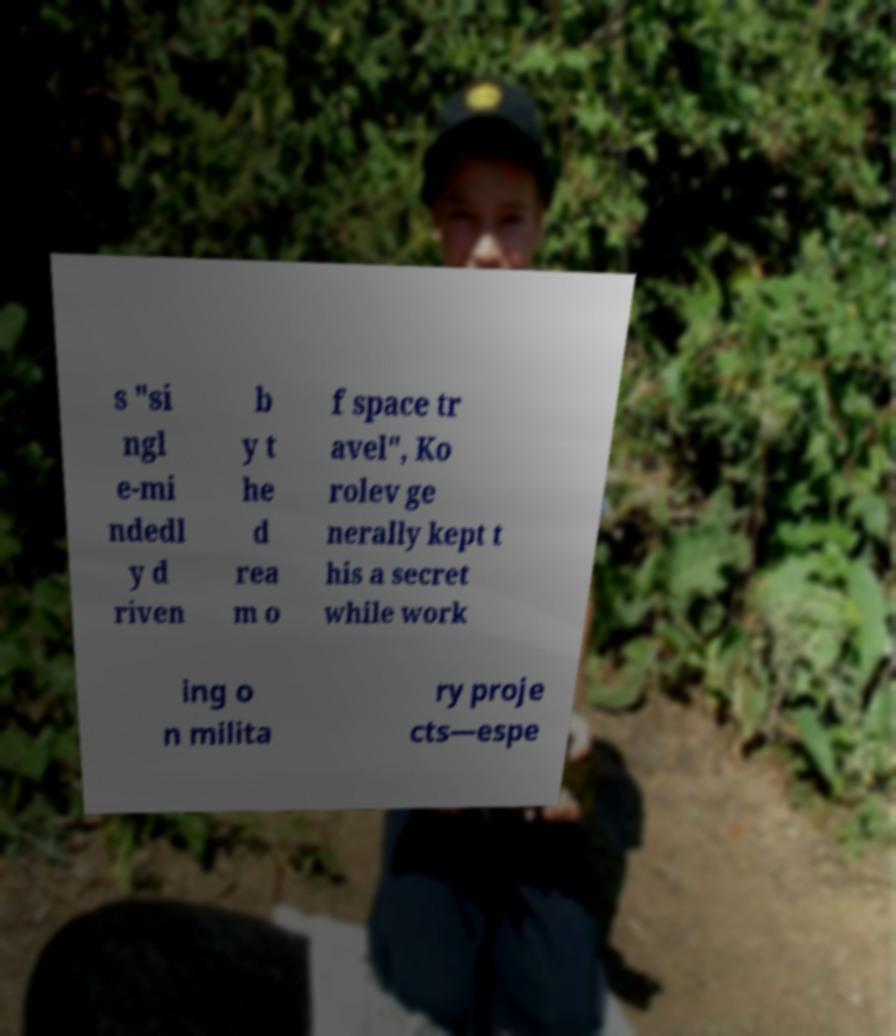There's text embedded in this image that I need extracted. Can you transcribe it verbatim? s "si ngl e-mi ndedl y d riven b y t he d rea m o f space tr avel", Ko rolev ge nerally kept t his a secret while work ing o n milita ry proje cts—espe 